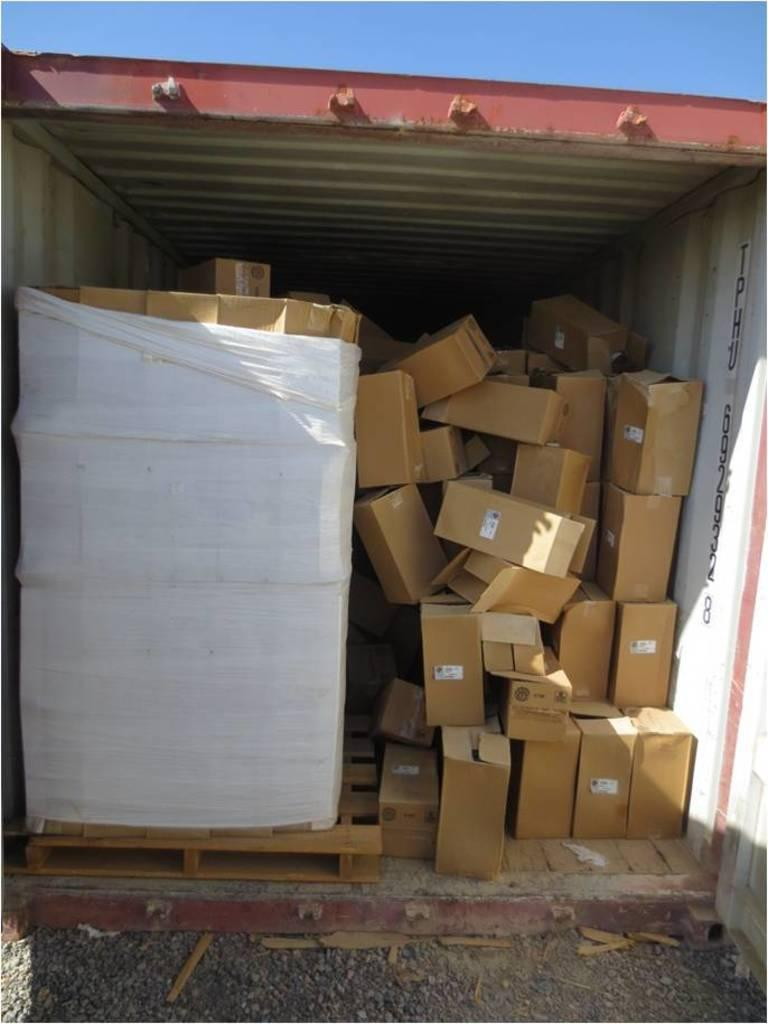What type of material is used to make the boxes in the image? The boxes in the image are made up of cardboard. What can be seen at the bottom of the image? The ground is visible at the bottom of the image. What type of structure is depicted in the image? The image appears to depict a metal cabin. What is visible at the top of the image? The sky is visible at the top of the image. Reasoning: Let's think step by step by following the given guidelines. We start by identifying the main subject in the image, which is the cardboard boxes. Then, we expand the conversation to include other elements that are also visible, such as the ground, the metal cabin, and the sky. Each question is designed to elicit a specific detail about the image that is known from the provided facts. Absurd Question/Answer: What substance is causing the throat irritation in the image? There is no indication of throat irritation or any substance causing it in the image. 